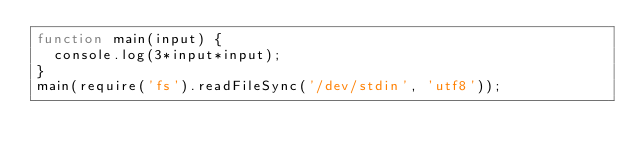Convert code to text. <code><loc_0><loc_0><loc_500><loc_500><_JavaScript_>function main(input) {
  console.log(3*input*input);
}
main(require('fs').readFileSync('/dev/stdin', 'utf8'));</code> 